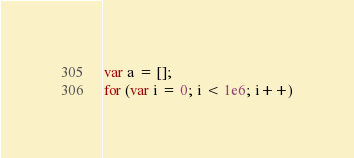<code> <loc_0><loc_0><loc_500><loc_500><_JavaScript_>var a = [];
for (var i = 0; i < 1e6; i++)</code> 